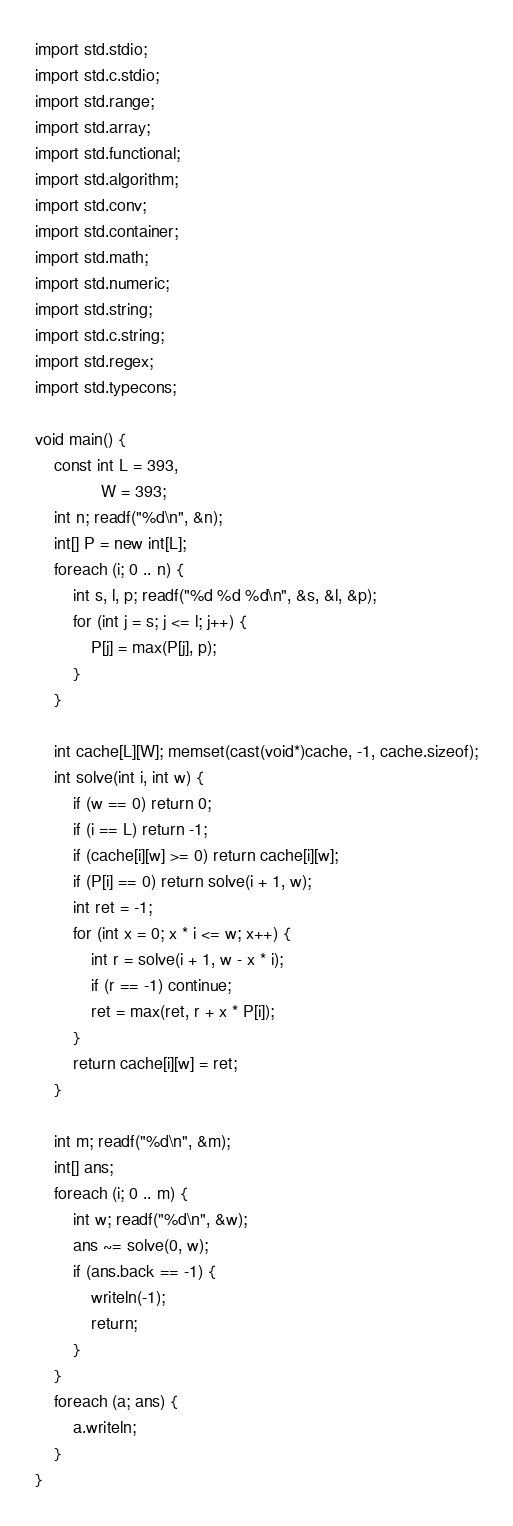<code> <loc_0><loc_0><loc_500><loc_500><_D_>import std.stdio;
import std.c.stdio;
import std.range;
import std.array;
import std.functional;
import std.algorithm;
import std.conv;
import std.container;
import std.math;
import std.numeric;
import std.string;
import std.c.string;
import std.regex;
import std.typecons;
 
void main() {
    const int L = 393,
              W = 393;
    int n; readf("%d\n", &n);
    int[] P = new int[L];
    foreach (i; 0 .. n) {
        int s, l, p; readf("%d %d %d\n", &s, &l, &p);
        for (int j = s; j <= l; j++) {
            P[j] = max(P[j], p);
        }
    }

    int cache[L][W]; memset(cast(void*)cache, -1, cache.sizeof);
    int solve(int i, int w) {
        if (w == 0) return 0;
        if (i == L) return -1;
        if (cache[i][w] >= 0) return cache[i][w];
        if (P[i] == 0) return solve(i + 1, w);
        int ret = -1;
        for (int x = 0; x * i <= w; x++) {
            int r = solve(i + 1, w - x * i);
            if (r == -1) continue;
            ret = max(ret, r + x * P[i]);
        }
        return cache[i][w] = ret;
    }

    int m; readf("%d\n", &m);
    int[] ans;
    foreach (i; 0 .. m) {
        int w; readf("%d\n", &w);
        ans ~= solve(0, w);
        if (ans.back == -1) {
            writeln(-1);
            return;
        }
    }
    foreach (a; ans) {
        a.writeln;
    }
}</code> 